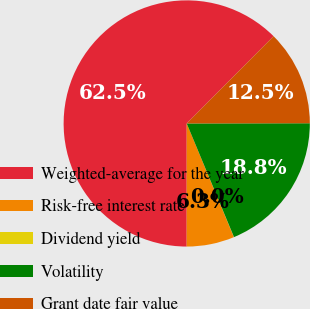Convert chart to OTSL. <chart><loc_0><loc_0><loc_500><loc_500><pie_chart><fcel>Weighted-average for the year<fcel>Risk-free interest rate<fcel>Dividend yield<fcel>Volatility<fcel>Grant date fair value<nl><fcel>62.46%<fcel>6.26%<fcel>0.02%<fcel>18.75%<fcel>12.51%<nl></chart> 